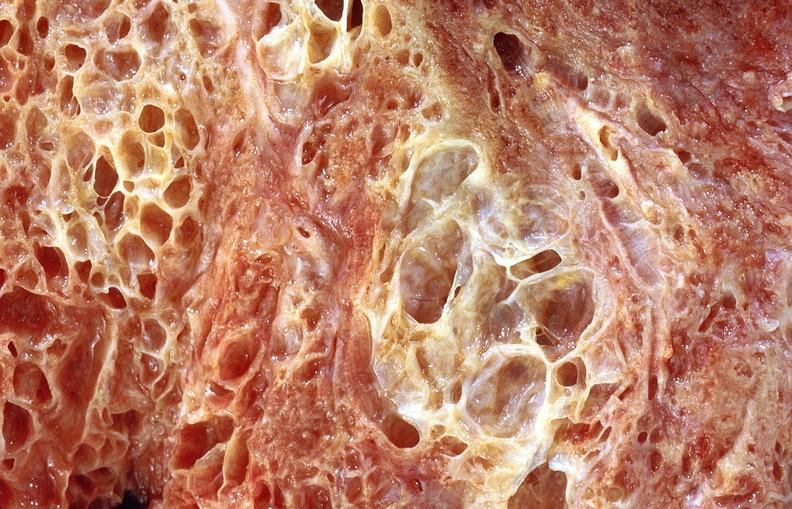where is this?
Answer the question using a single word or phrase. Lung 